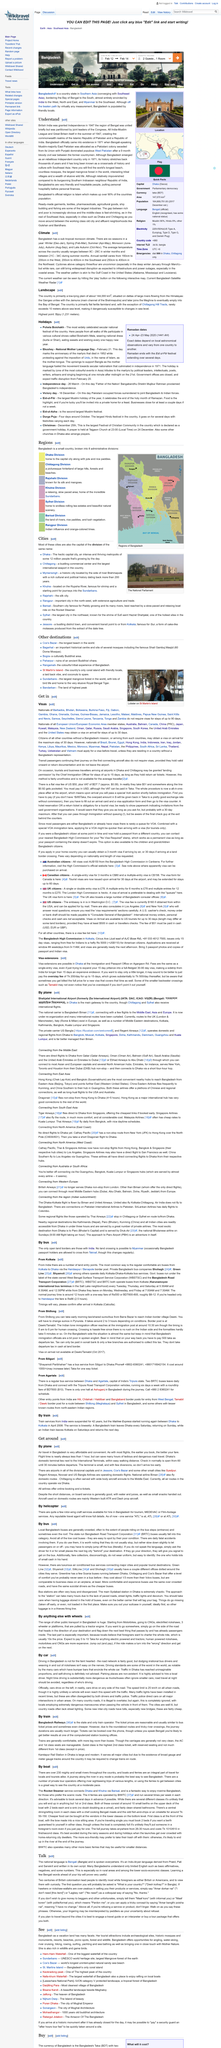Outline some significant characteristics in this image. Dhaka's domestic terminal is in close proximity to the international terminals, allowing for easy access and seamless transfers for travelers. All air routes currently operate via Dhaka, according to the article "Get around". Check-in at Dhaka's domestic terminal typically opens between 60 to 30 minutes before the scheduled departure time. 